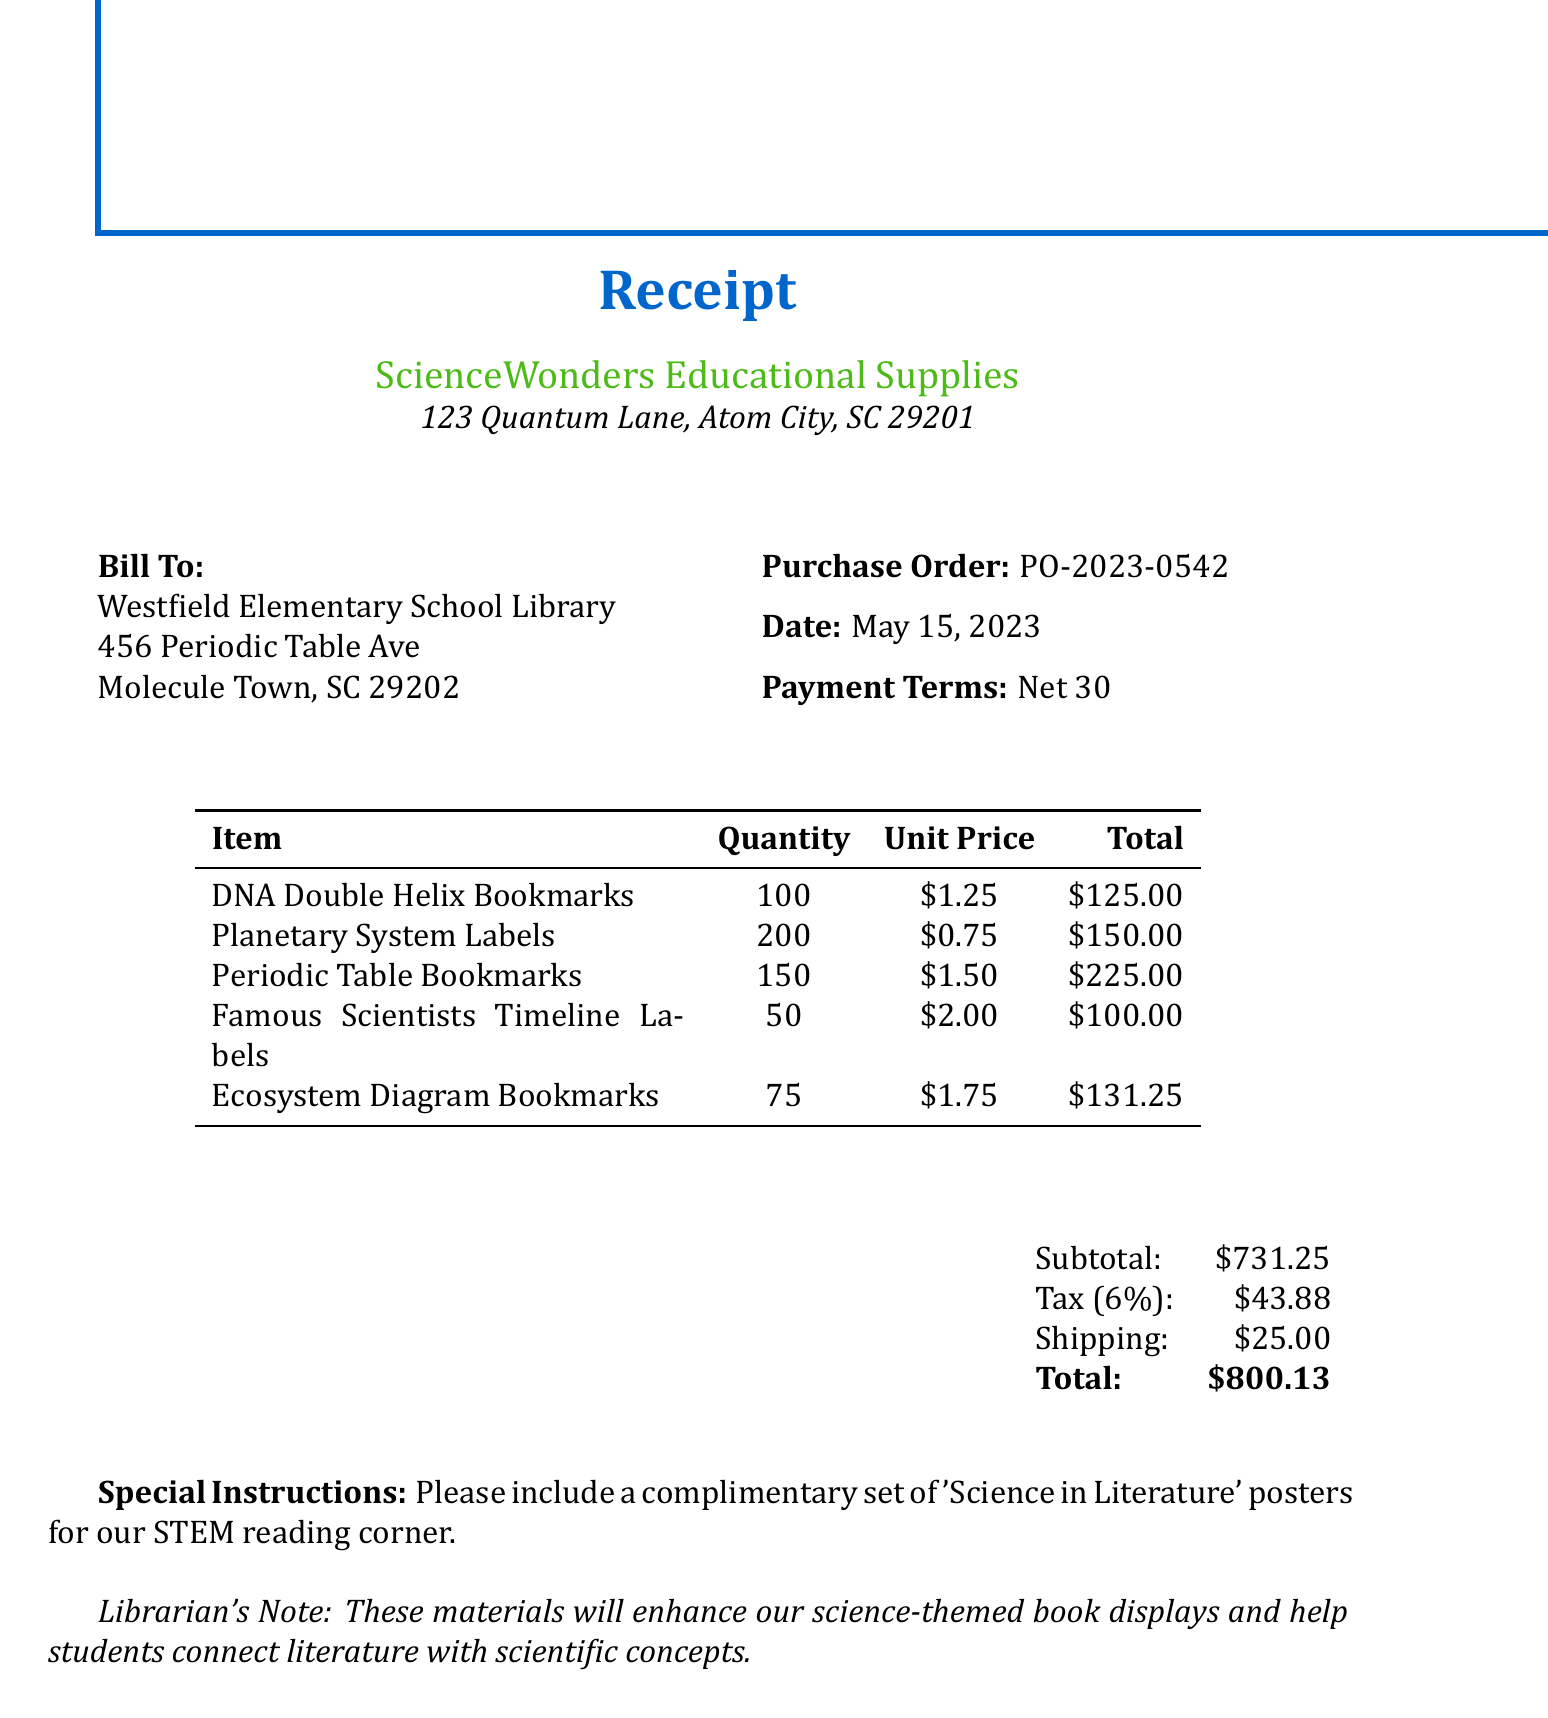What is the vendor name? The vendor name is listed at the top of the receipt as the supplier of the items.
Answer: ScienceWonders Educational Supplies What is the purchase order number? The purchase order number is clearly indicated in the document as a unique identifier for this transaction.
Answer: PO-2023-0542 What is the total amount due? The total amount due is typically found at the bottom section, summarizing all expenses including tax and shipping.
Answer: $800.13 How many DNA Double Helix Bookmarks were ordered? The quantity ordered is specified for each item in the itemized list in the center of the document.
Answer: 100 What is the tax rate applied to the purchase? The tax rate is stated in the financial summary section, indicating the percentage applied to the subtotal.
Answer: 6% Which item has the highest unit price? This question requires comparing the unit prices listed, which are itemized in the table format.
Answer: Periodic Table Bookmarks What special instructions were provided? The special instructions section outlines any additional requests or notes related to the order.
Answer: Please include a complimentary set of 'Science in Literature' posters for our STEM reading corner What is the date of the purchase order? The date can be found near the purchase order number, indicating when the order was placed.
Answer: May 15, 2023 What is noted in the librarian's note? The librarian's note provides context related to the use of the ordered items, focusing on educational purposes.
Answer: These materials will enhance our science-themed book displays and help students connect literature with scientific concepts 